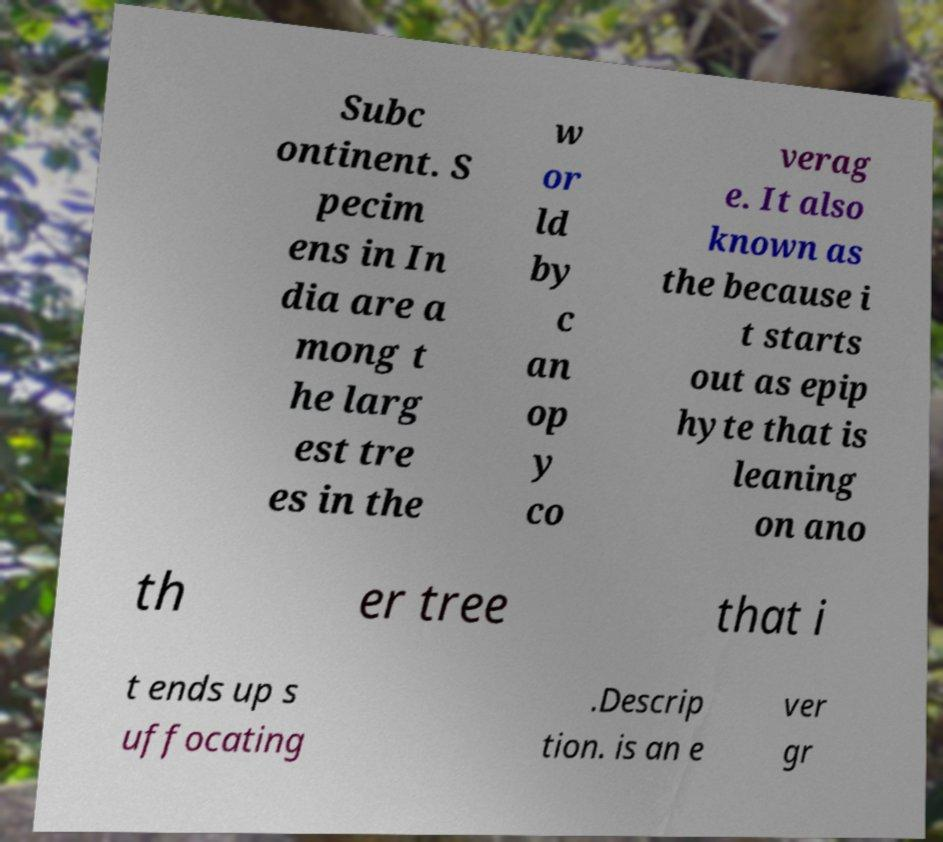There's text embedded in this image that I need extracted. Can you transcribe it verbatim? Subc ontinent. S pecim ens in In dia are a mong t he larg est tre es in the w or ld by c an op y co verag e. It also known as the because i t starts out as epip hyte that is leaning on ano th er tree that i t ends up s uffocating .Descrip tion. is an e ver gr 